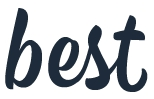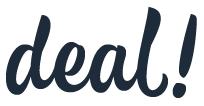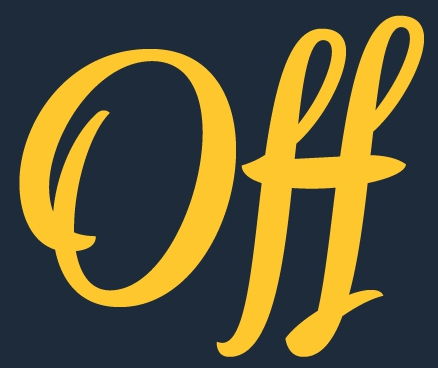What words can you see in these images in sequence, separated by a semicolon? best; deal!; Off 